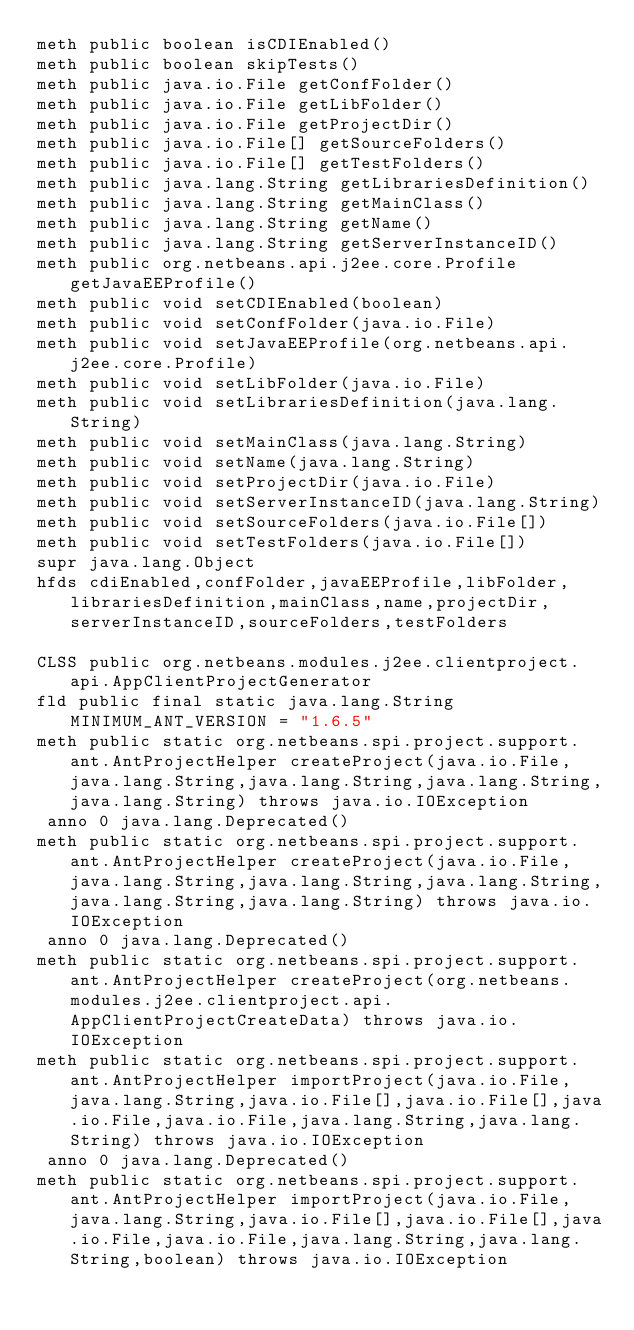Convert code to text. <code><loc_0><loc_0><loc_500><loc_500><_SML_>meth public boolean isCDIEnabled()
meth public boolean skipTests()
meth public java.io.File getConfFolder()
meth public java.io.File getLibFolder()
meth public java.io.File getProjectDir()
meth public java.io.File[] getSourceFolders()
meth public java.io.File[] getTestFolders()
meth public java.lang.String getLibrariesDefinition()
meth public java.lang.String getMainClass()
meth public java.lang.String getName()
meth public java.lang.String getServerInstanceID()
meth public org.netbeans.api.j2ee.core.Profile getJavaEEProfile()
meth public void setCDIEnabled(boolean)
meth public void setConfFolder(java.io.File)
meth public void setJavaEEProfile(org.netbeans.api.j2ee.core.Profile)
meth public void setLibFolder(java.io.File)
meth public void setLibrariesDefinition(java.lang.String)
meth public void setMainClass(java.lang.String)
meth public void setName(java.lang.String)
meth public void setProjectDir(java.io.File)
meth public void setServerInstanceID(java.lang.String)
meth public void setSourceFolders(java.io.File[])
meth public void setTestFolders(java.io.File[])
supr java.lang.Object
hfds cdiEnabled,confFolder,javaEEProfile,libFolder,librariesDefinition,mainClass,name,projectDir,serverInstanceID,sourceFolders,testFolders

CLSS public org.netbeans.modules.j2ee.clientproject.api.AppClientProjectGenerator
fld public final static java.lang.String MINIMUM_ANT_VERSION = "1.6.5"
meth public static org.netbeans.spi.project.support.ant.AntProjectHelper createProject(java.io.File,java.lang.String,java.lang.String,java.lang.String,java.lang.String) throws java.io.IOException
 anno 0 java.lang.Deprecated()
meth public static org.netbeans.spi.project.support.ant.AntProjectHelper createProject(java.io.File,java.lang.String,java.lang.String,java.lang.String,java.lang.String,java.lang.String) throws java.io.IOException
 anno 0 java.lang.Deprecated()
meth public static org.netbeans.spi.project.support.ant.AntProjectHelper createProject(org.netbeans.modules.j2ee.clientproject.api.AppClientProjectCreateData) throws java.io.IOException
meth public static org.netbeans.spi.project.support.ant.AntProjectHelper importProject(java.io.File,java.lang.String,java.io.File[],java.io.File[],java.io.File,java.io.File,java.lang.String,java.lang.String) throws java.io.IOException
 anno 0 java.lang.Deprecated()
meth public static org.netbeans.spi.project.support.ant.AntProjectHelper importProject(java.io.File,java.lang.String,java.io.File[],java.io.File[],java.io.File,java.io.File,java.lang.String,java.lang.String,boolean) throws java.io.IOException</code> 